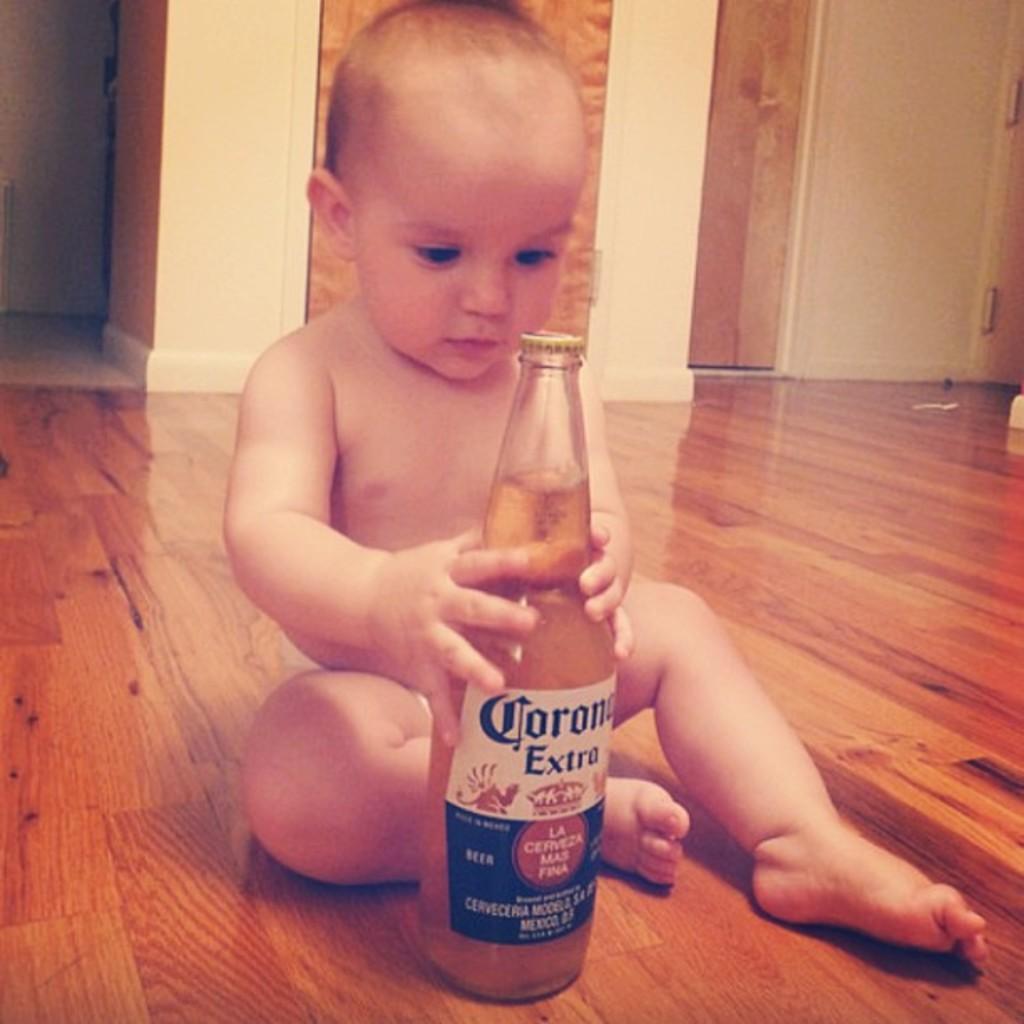In one or two sentences, can you explain what this image depicts? There is one kid sitting on the floor and holding a bottle as we can see in the middle of this image. There is a wall in the background. 